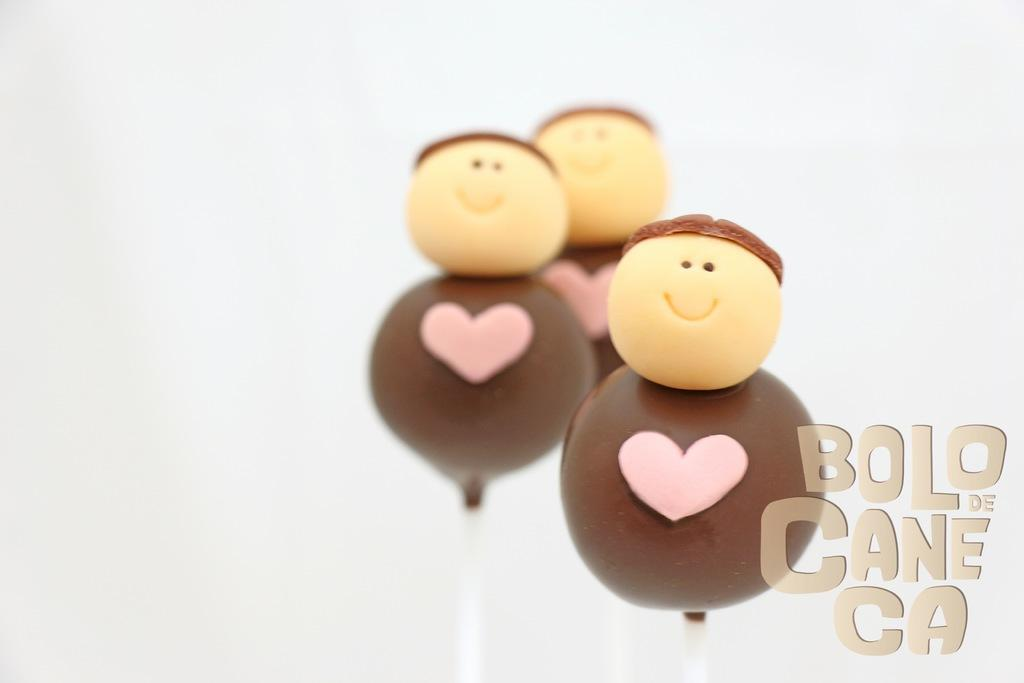What type of candy can be seen in the image? There are candy sticks in the image. Is there any text present in the image? Yes, there is text at the bottom of the image. What type of shock can be seen in the image? There is no shock present in the image; it features candy sticks and text. Can you see a robin in the image? No, there is no robin present in the image. 